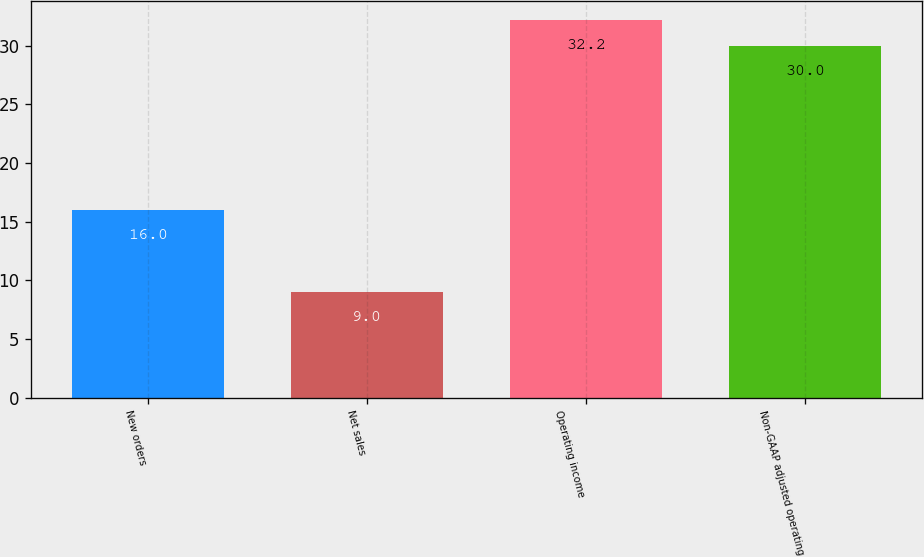Convert chart to OTSL. <chart><loc_0><loc_0><loc_500><loc_500><bar_chart><fcel>New orders<fcel>Net sales<fcel>Operating income<fcel>Non-GAAP adjusted operating<nl><fcel>16<fcel>9<fcel>32.2<fcel>30<nl></chart> 